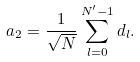Convert formula to latex. <formula><loc_0><loc_0><loc_500><loc_500>a _ { 2 } = \frac { 1 } { \sqrt { N } } \sum _ { l = 0 } ^ { N ^ { \prime } - 1 } d _ { l } .</formula> 